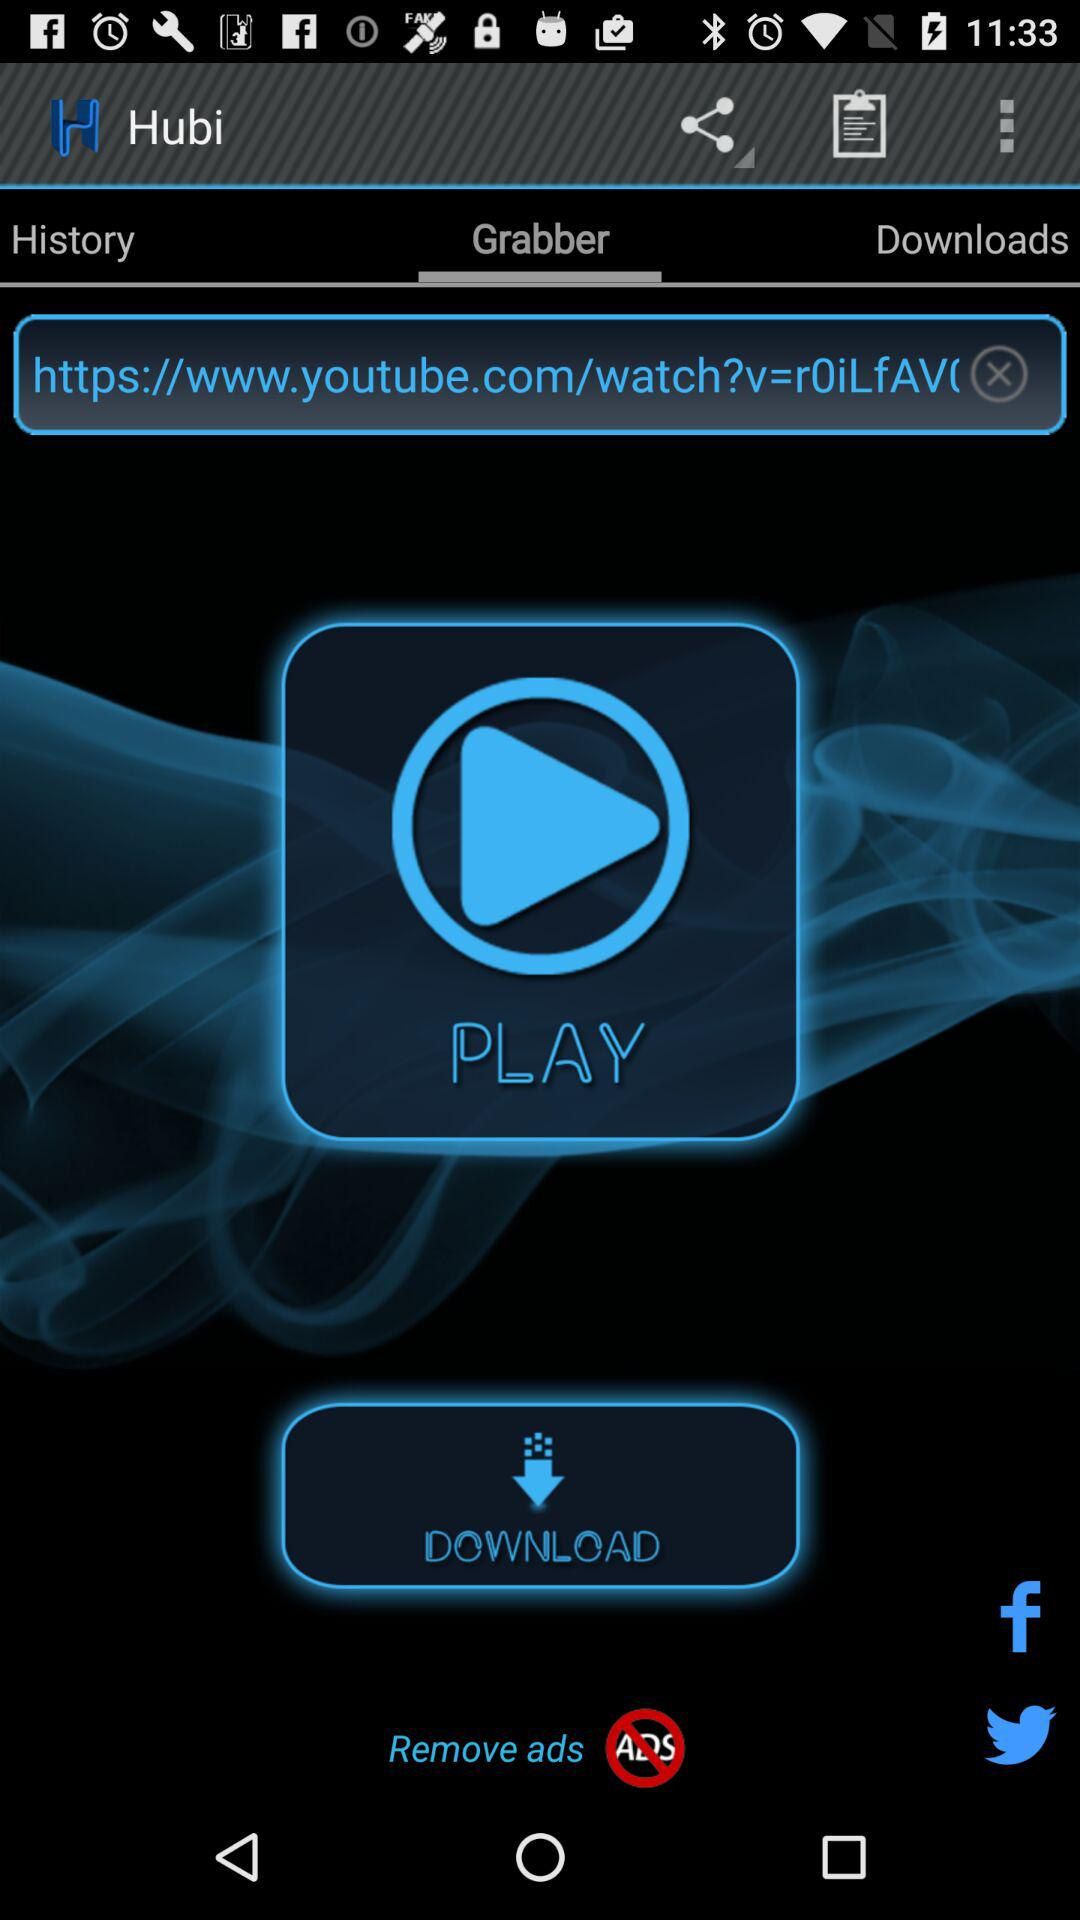Which tab is selected? The selected tab is "Grabber". 